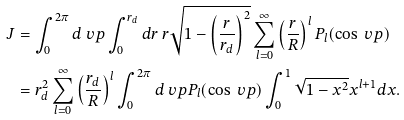<formula> <loc_0><loc_0><loc_500><loc_500>J & = \int _ { 0 } ^ { 2 \pi } d \ v p \int _ { 0 } ^ { r _ { d } } d r \, r \sqrt { 1 - \left ( \frac { r } { r _ { d } } \right ) ^ { 2 } } \sum _ { l = 0 } ^ { \infty } \left ( \frac { r } { R } \right ) ^ { l } P _ { l } ( \cos \ v p ) \\ & = r _ { d } ^ { 2 } \sum _ { l = 0 } ^ { \infty } \left ( \frac { r _ { d } } { R } \right ) ^ { l } \int _ { 0 } ^ { 2 \pi } d \ v p P _ { l } ( \cos \ v p ) \int _ { 0 } ^ { 1 } \sqrt { 1 - x ^ { 2 } } x ^ { l + 1 } d x .</formula> 